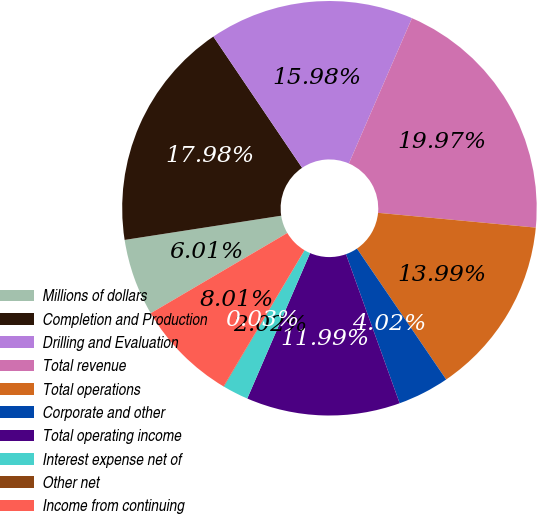Convert chart to OTSL. <chart><loc_0><loc_0><loc_500><loc_500><pie_chart><fcel>Millions of dollars<fcel>Completion and Production<fcel>Drilling and Evaluation<fcel>Total revenue<fcel>Total operations<fcel>Corporate and other<fcel>Total operating income<fcel>Interest expense net of<fcel>Other net<fcel>Income from continuing<nl><fcel>6.01%<fcel>17.98%<fcel>15.98%<fcel>19.97%<fcel>13.99%<fcel>4.02%<fcel>11.99%<fcel>2.02%<fcel>0.03%<fcel>8.01%<nl></chart> 